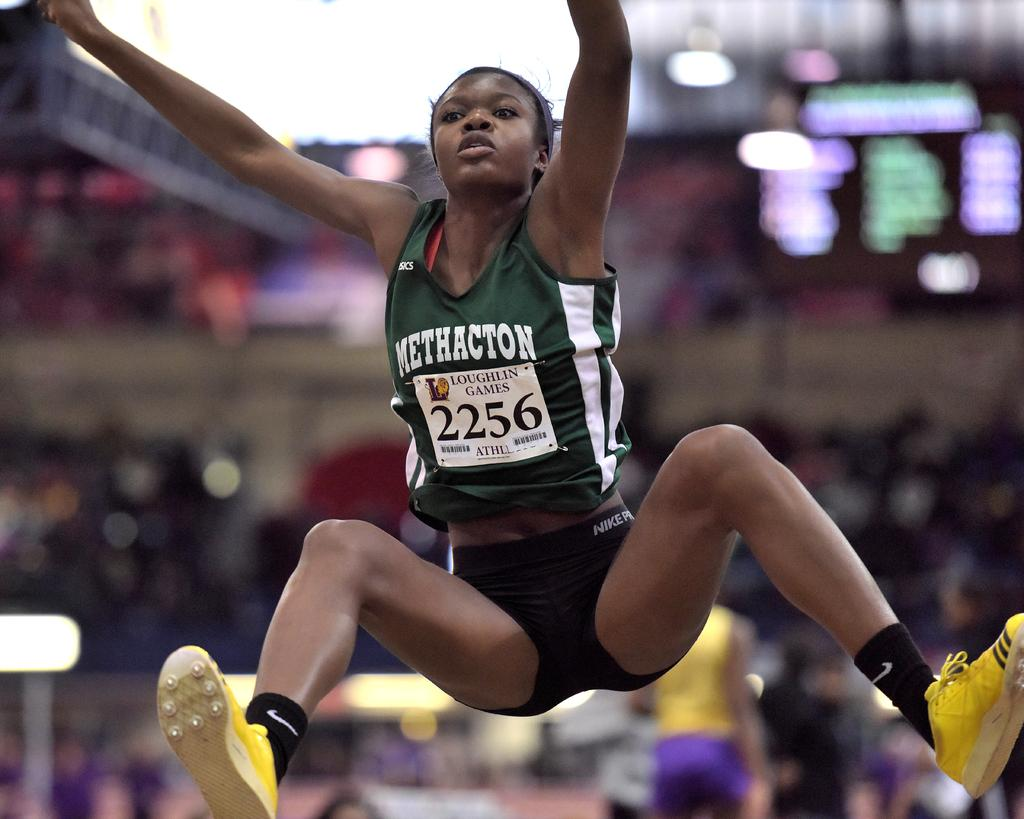<image>
Relay a brief, clear account of the picture shown. a woman in a 2256 bib doing a long jump in the air 